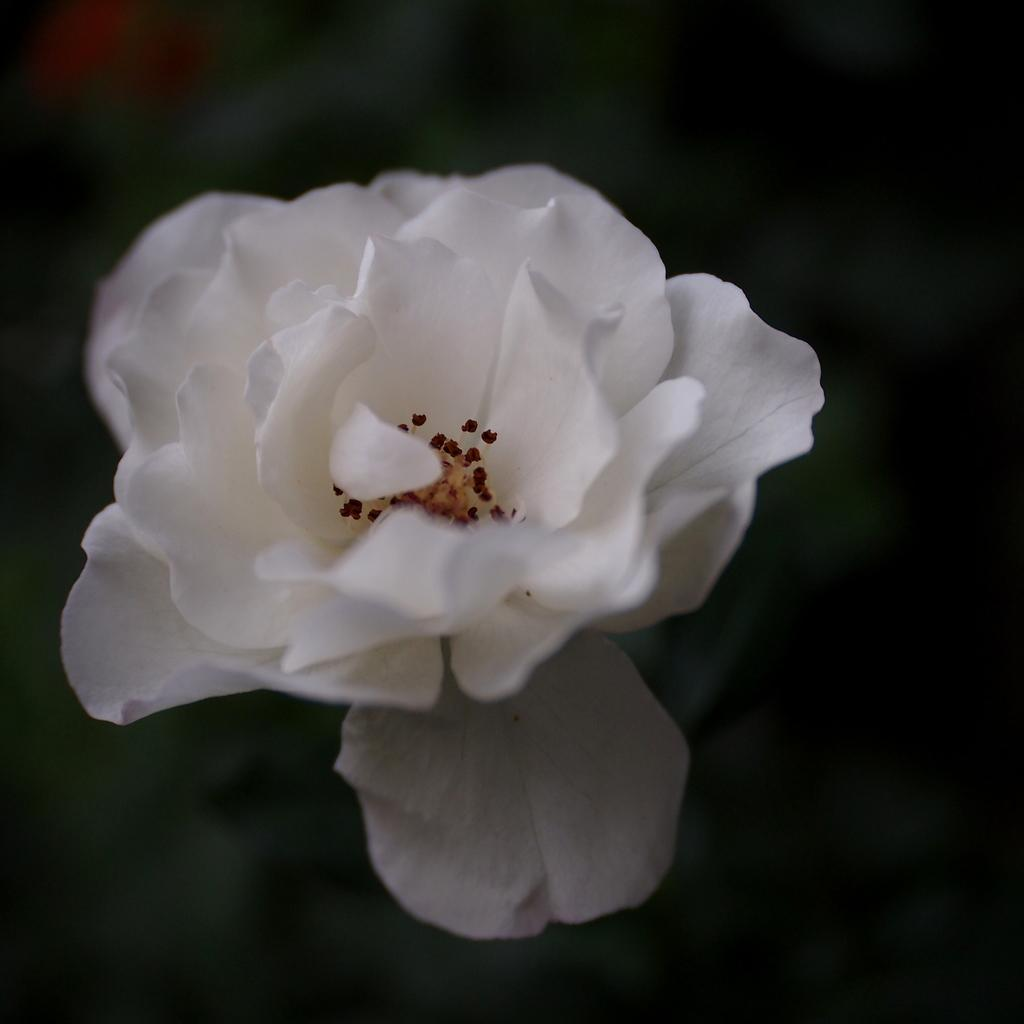What is the main subject of the image? There is a flower in the image. Can you describe the color of the flower? The flower is white in color. How many fingers can be seen holding the flower in the image? There is no hand or fingers holding the flower in the image; it is simply a white flower. What type of amphibian is present near the flower in the image? There is no amphibian, such as a toad, present in the image; it only features a white flower. 